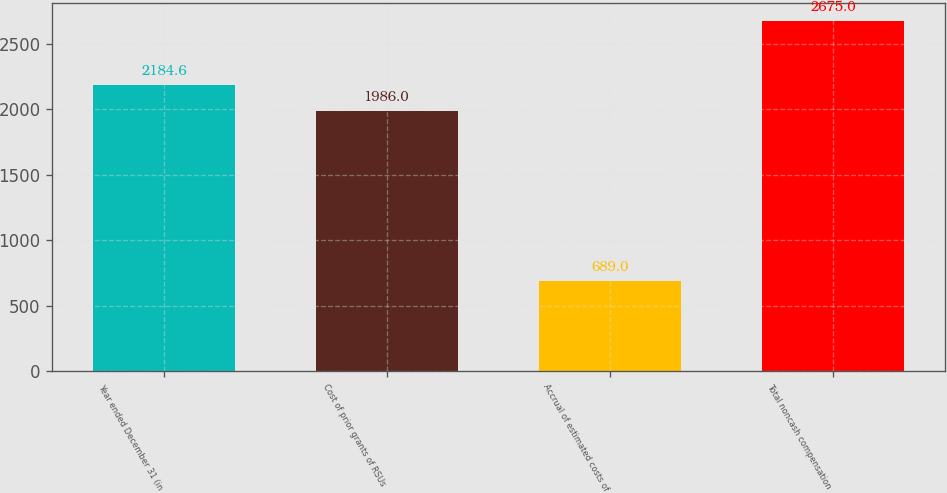Convert chart. <chart><loc_0><loc_0><loc_500><loc_500><bar_chart><fcel>Year ended December 31 (in<fcel>Cost of prior grants of RSUs<fcel>Accrual of estimated costs of<fcel>Total noncash compensation<nl><fcel>2184.6<fcel>1986<fcel>689<fcel>2675<nl></chart> 